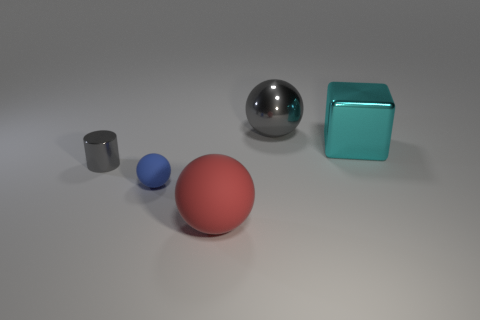Subtract all large red spheres. How many spheres are left? 2 Subtract all blue spheres. How many spheres are left? 2 Subtract 3 balls. How many balls are left? 0 Add 3 large shiny cubes. How many objects exist? 8 Subtract all cubes. How many objects are left? 4 Subtract 0 yellow spheres. How many objects are left? 5 Subtract all brown balls. Subtract all purple cylinders. How many balls are left? 3 Subtract all purple cubes. How many blue cylinders are left? 0 Subtract all cyan cubes. Subtract all big red balls. How many objects are left? 3 Add 1 metal objects. How many metal objects are left? 4 